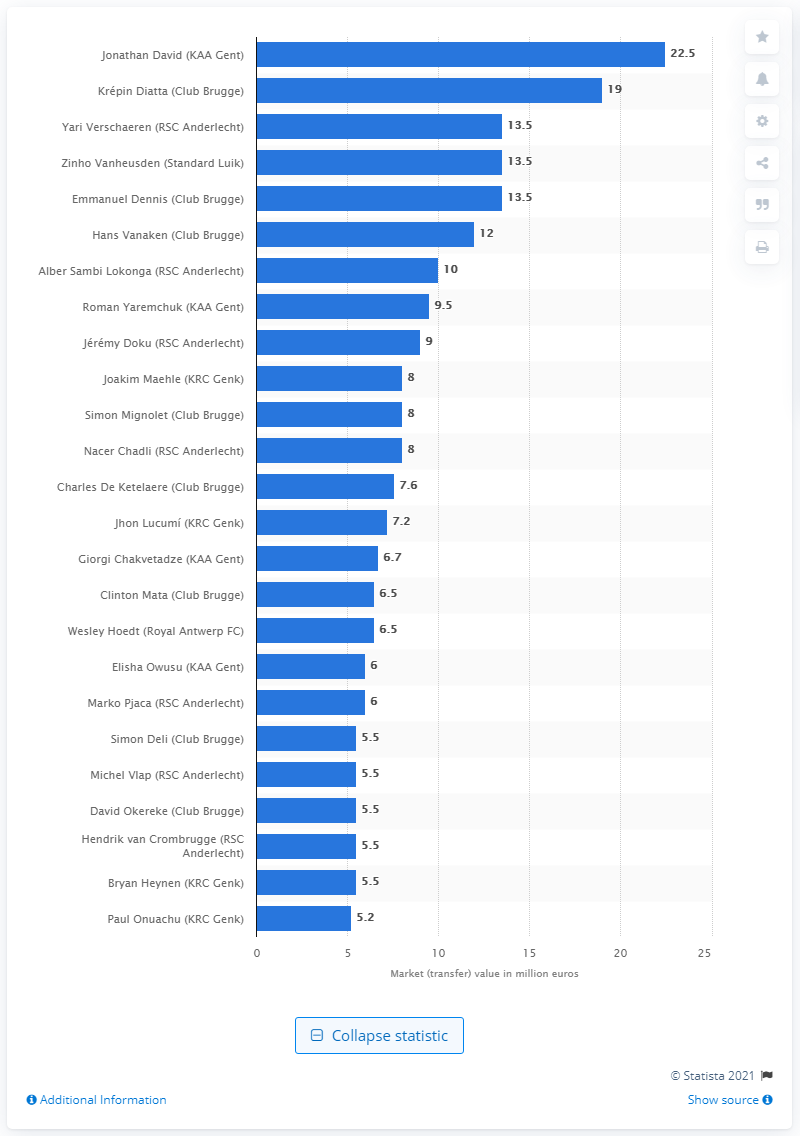Point out several critical features in this image. As of April 2020, the market value of Jonathan David in the Belgian football league was 22.5 million dollars. The market value of Krpin Diatta was approximately $19 million in 2023. 